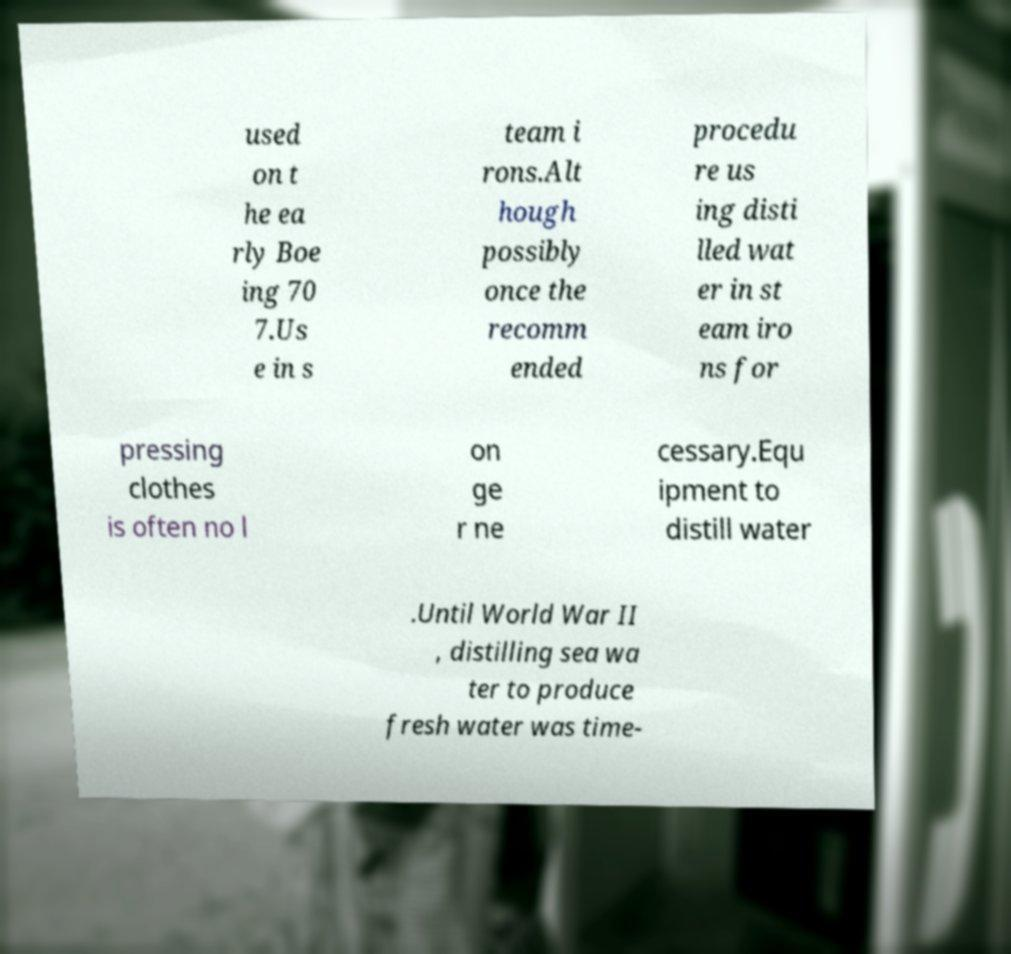Please read and relay the text visible in this image. What does it say? used on t he ea rly Boe ing 70 7.Us e in s team i rons.Alt hough possibly once the recomm ended procedu re us ing disti lled wat er in st eam iro ns for pressing clothes is often no l on ge r ne cessary.Equ ipment to distill water .Until World War II , distilling sea wa ter to produce fresh water was time- 